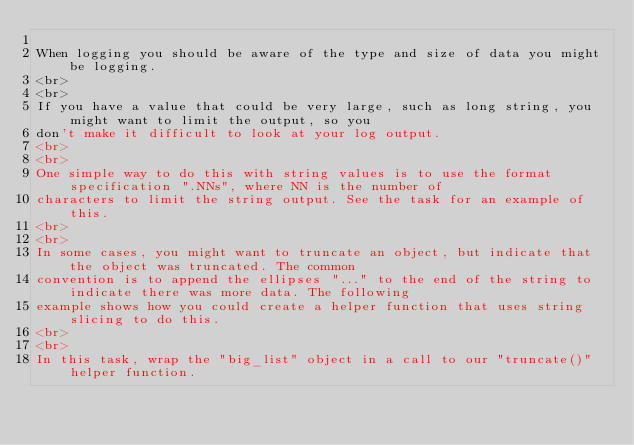Convert code to text. <code><loc_0><loc_0><loc_500><loc_500><_HTML_>
When logging you should be aware of the type and size of data you might be logging.
<br>
<br>
If you have a value that could be very large, such as long string, you might want to limit the output, so you
don't make it difficult to look at your log output.
<br>
<br>
One simple way to do this with string values is to use the format specification ".NNs", where NN is the number of
characters to limit the string output. See the task for an example of this.
<br>
<br>
In some cases, you might want to truncate an object, but indicate that the object was truncated. The common
convention is to append the ellipses "..." to the end of the string to indicate there was more data. The following
example shows how you could create a helper function that uses string slicing to do this.
<br>
<br>
In this task, wrap the "big_list" object in a call to our "truncate()" helper function.
</code> 